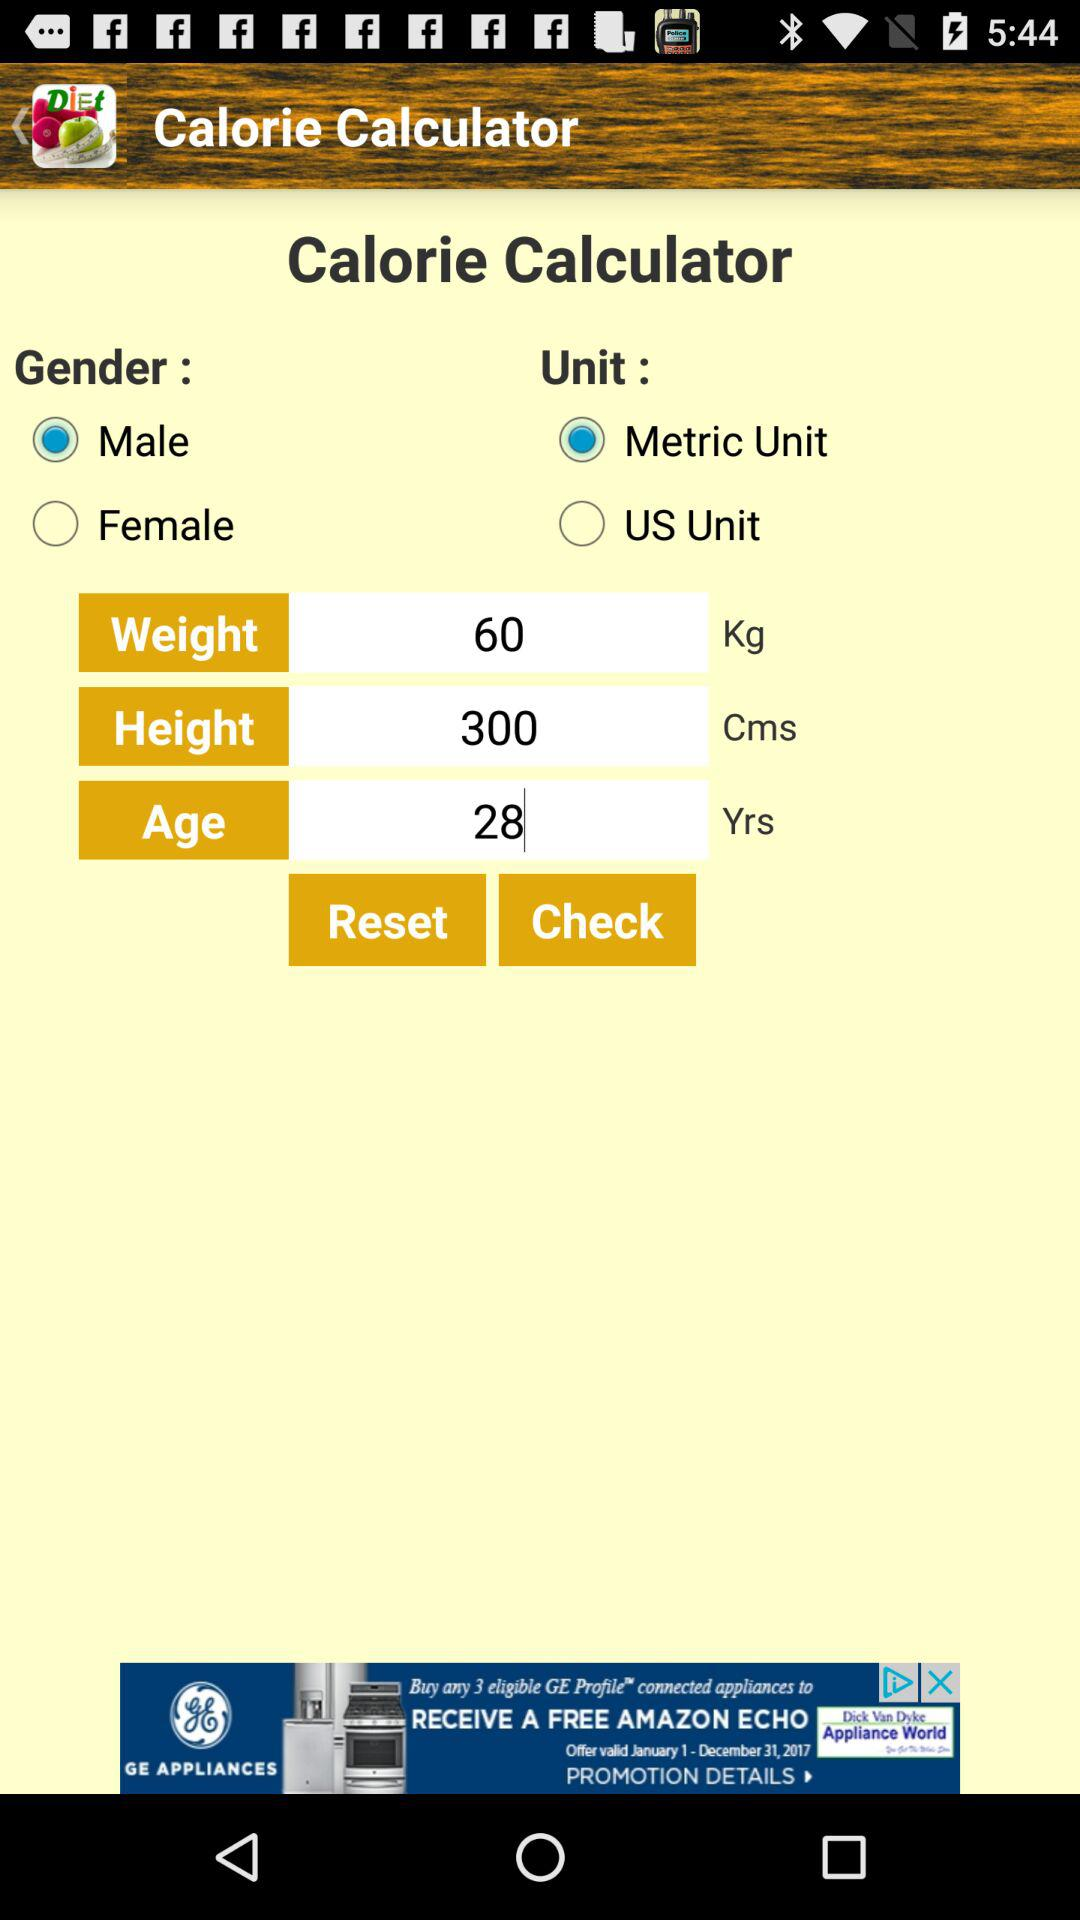What is the name of the application? The name of the application is "Calorie Calculator". 